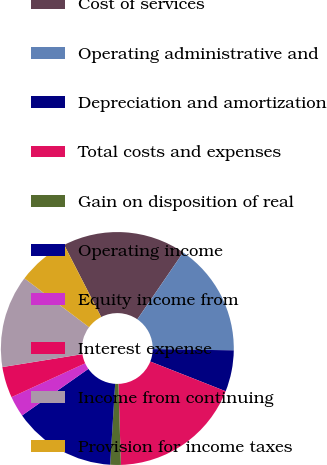Convert chart to OTSL. <chart><loc_0><loc_0><loc_500><loc_500><pie_chart><fcel>Cost of services<fcel>Operating administrative and<fcel>Depreciation and amortization<fcel>Total costs and expenses<fcel>Gain on disposition of real<fcel>Operating income<fcel>Equity income from<fcel>Interest expense<fcel>Income from continuing<fcel>Provision for income taxes<nl><fcel>17.11%<fcel>15.69%<fcel>5.73%<fcel>18.53%<fcel>1.47%<fcel>14.27%<fcel>2.89%<fcel>4.31%<fcel>12.84%<fcel>7.16%<nl></chart> 